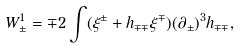Convert formula to latex. <formula><loc_0><loc_0><loc_500><loc_500>W _ { \pm } ^ { 1 } = \mp 2 \int ( \xi ^ { \pm } + h _ { \mp \mp } \xi ^ { \mp } ) ( \partial _ { \pm } ) ^ { 3 } h _ { \mp \mp } ,</formula> 